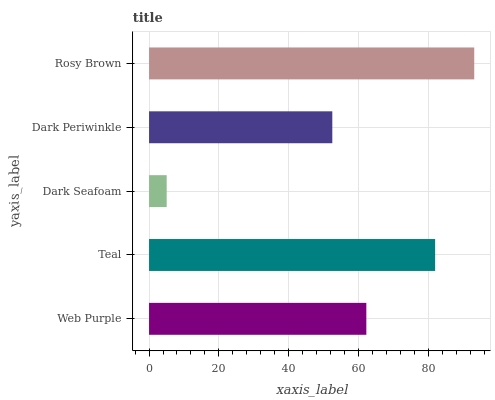Is Dark Seafoam the minimum?
Answer yes or no. Yes. Is Rosy Brown the maximum?
Answer yes or no. Yes. Is Teal the minimum?
Answer yes or no. No. Is Teal the maximum?
Answer yes or no. No. Is Teal greater than Web Purple?
Answer yes or no. Yes. Is Web Purple less than Teal?
Answer yes or no. Yes. Is Web Purple greater than Teal?
Answer yes or no. No. Is Teal less than Web Purple?
Answer yes or no. No. Is Web Purple the high median?
Answer yes or no. Yes. Is Web Purple the low median?
Answer yes or no. Yes. Is Dark Periwinkle the high median?
Answer yes or no. No. Is Teal the low median?
Answer yes or no. No. 